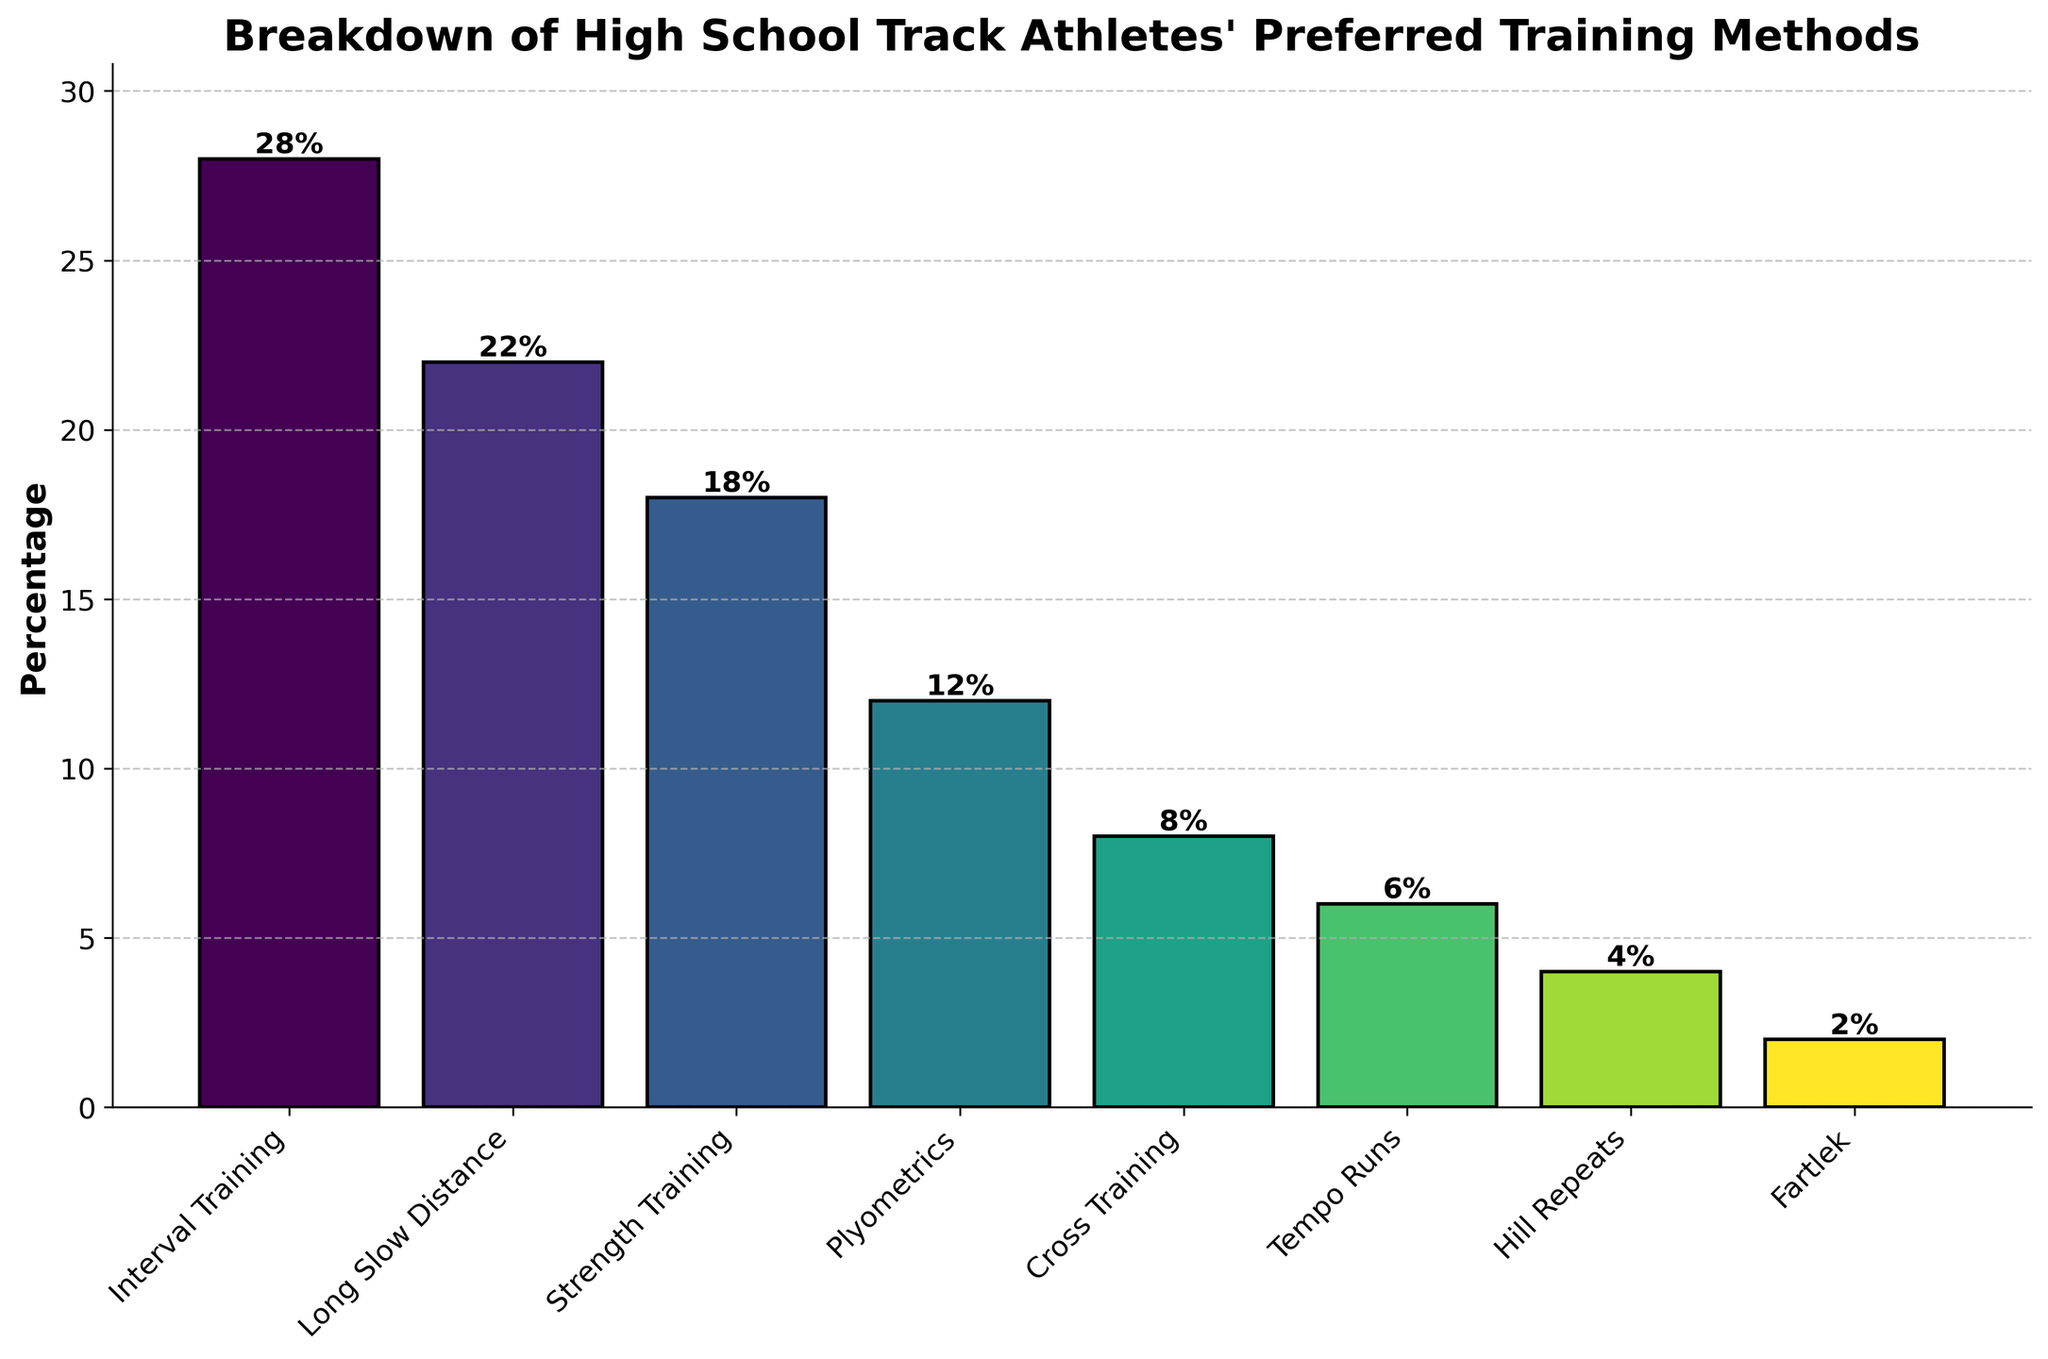Which training method is the most preferred by high school track athletes? By looking at the figure, the tallest bar represents the most preferred training method. The label on the x-axis for the tallest bar reads "Interval Training," which corresponds to 28%.
Answer: Interval Training Which training method is the least preferred by high school track athletes? By observing the shortest bar on the chart, the least preferred training method is the one labeled "Fartlek" with a percentage of 2%.
Answer: Fartlek Compare the percentage of high school track athletes who prefer Interval Training to those who prefer Long Slow Distance. Which has a higher percentage and by how much? Interval Training has a percentage of 28%, and Long Slow Distance has 22%. Subtracting the two gives 28% - 22% = 6%. Interval Training has a higher percentage by 6%.
Answer: Interval Training by 6% What is the combined percentage of athletes who prefer Strength Training and Plyometrics? The percentage for Strength Training is 18%, and for Plyometrics, it is 12%. Adding them together gives 18% + 12% = 30%.
Answer: 30% How does the percentage of athletes who prefer Cross Training compare to those who prefer Tempo Runs? Cross Training is preferred by 8% of athletes, while Tempo Runs are preferred by 6%. This means more athletes prefer Cross Training by 8% - 6% = 2%.
Answer: Cross Training by 2% What is the difference in the percentages between the most and least preferred training methods? The most preferred training method is Interval Training with 28%, and the least preferred is Fartlek with 2%. The difference is 28% - 2% = 26%.
Answer: 26% Which training methods have a percentage higher than 15%? By examining the bars taller than the 15% mark on the y-axis, the methods with percentages higher than 15% are Interval Training (28%), Long Slow Distance (22%), and Strength Training (18%).
Answer: Interval Training, Long Slow Distance, Strength Training How much more preferred is Strength Training compared to Hill Repeats? Strength Training is preferred by 18% of athletes, while Hill Repeats are preferred by 4%. The difference is 18% - 4% = 14%.
Answer: 14% What is the sum of the percentages of the three least preferred training methods? The three least preferred methods are Fartlek (2%), Hill Repeats (4%), and Tempo Runs (6%). Adding them gives 2% + 4% + 6% = 12%.
Answer: 12% Which two training methods have a preference difference of exactly 10%? Comparing the percentages for each possible pair, Strength Training is preferred by 18%, and Cross Training by 8%. The difference between them is 18% - 8% = 10%.
Answer: Strength Training and Cross Training 